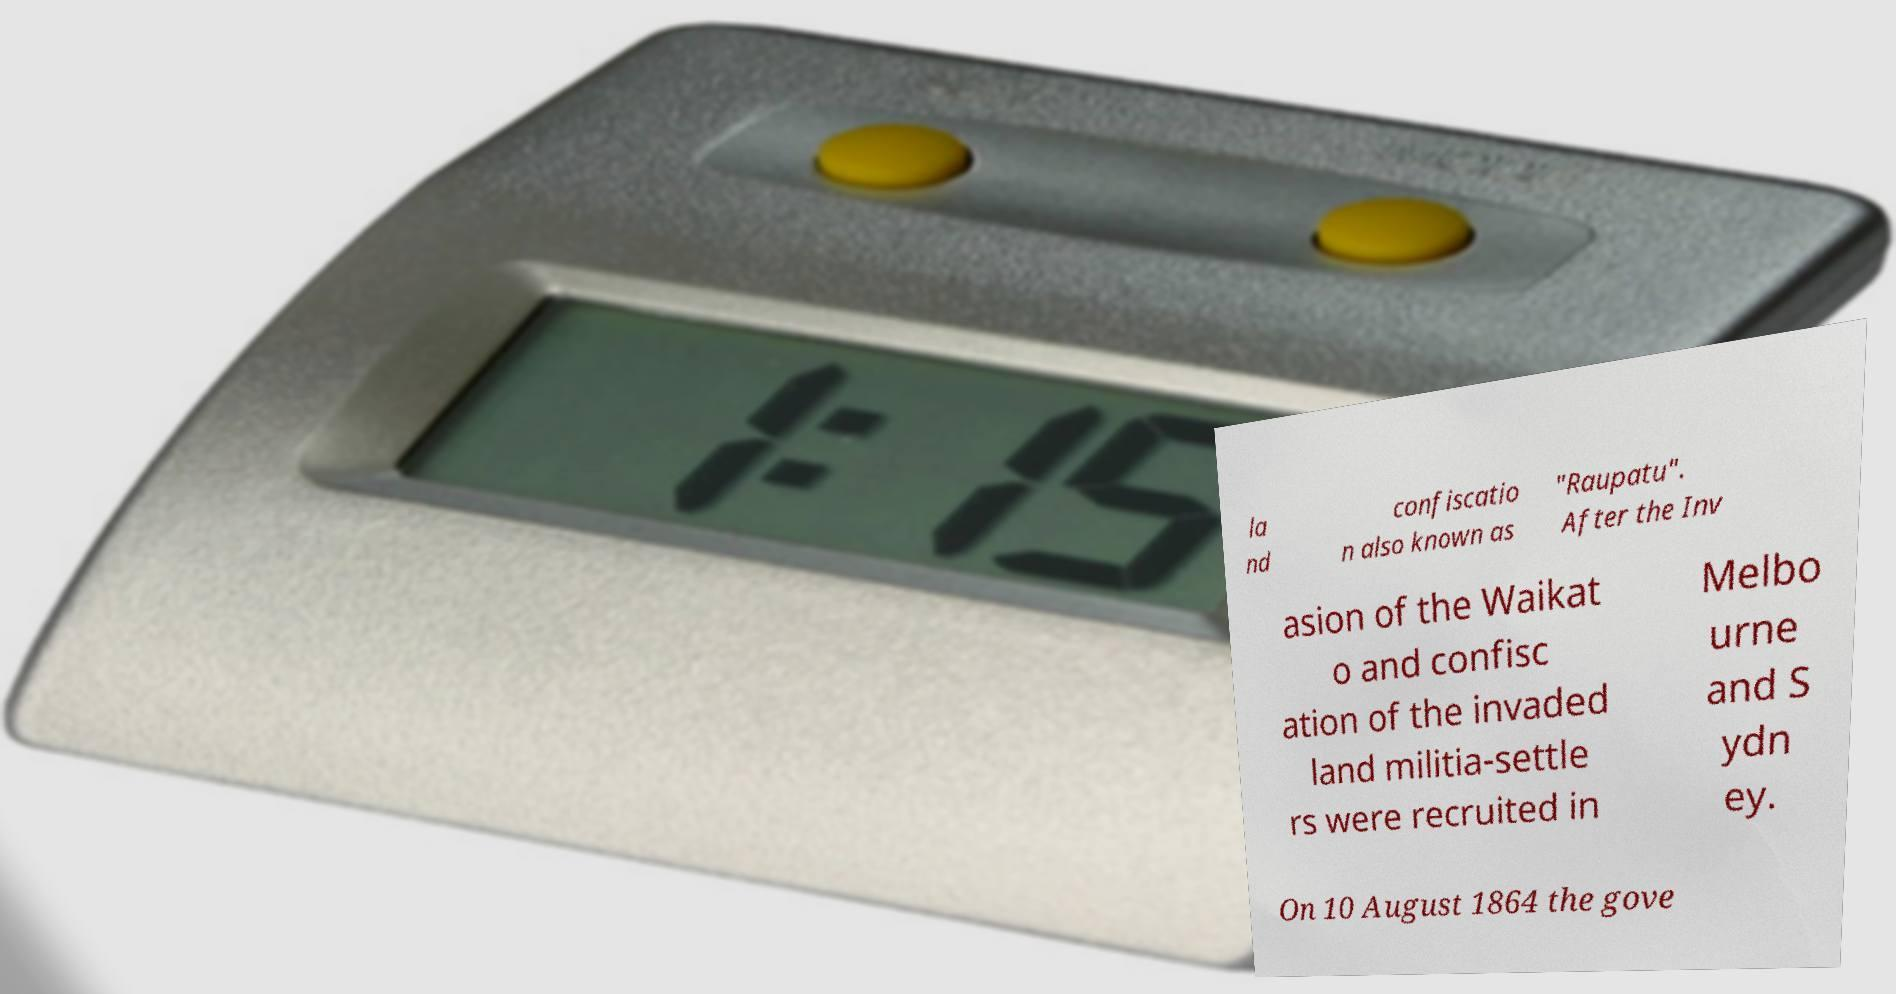For documentation purposes, I need the text within this image transcribed. Could you provide that? la nd confiscatio n also known as "Raupatu". After the Inv asion of the Waikat o and confisc ation of the invaded land militia-settle rs were recruited in Melbo urne and S ydn ey. On 10 August 1864 the gove 